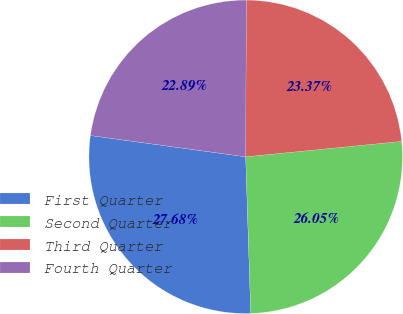Convert chart to OTSL. <chart><loc_0><loc_0><loc_500><loc_500><pie_chart><fcel>First Quarter<fcel>Second Quarter<fcel>Third Quarter<fcel>Fourth Quarter<nl><fcel>27.68%<fcel>26.05%<fcel>23.37%<fcel>22.89%<nl></chart> 